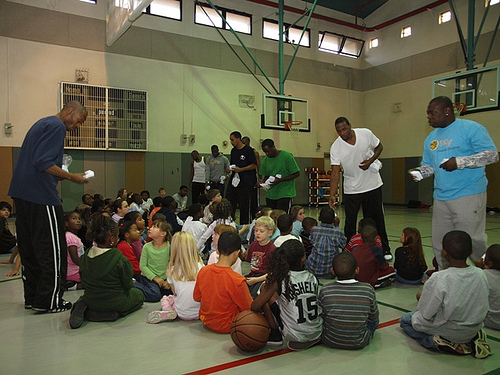<image>
Is there a man on the floor? Yes. Looking at the image, I can see the man is positioned on top of the floor, with the floor providing support. Where is the girl in relation to the ball? Is it on the ball? No. The girl is not positioned on the ball. They may be near each other, but the girl is not supported by or resting on top of the ball. Where is the man in relation to the boy? Is it behind the boy? Yes. From this viewpoint, the man is positioned behind the boy, with the boy partially or fully occluding the man. 